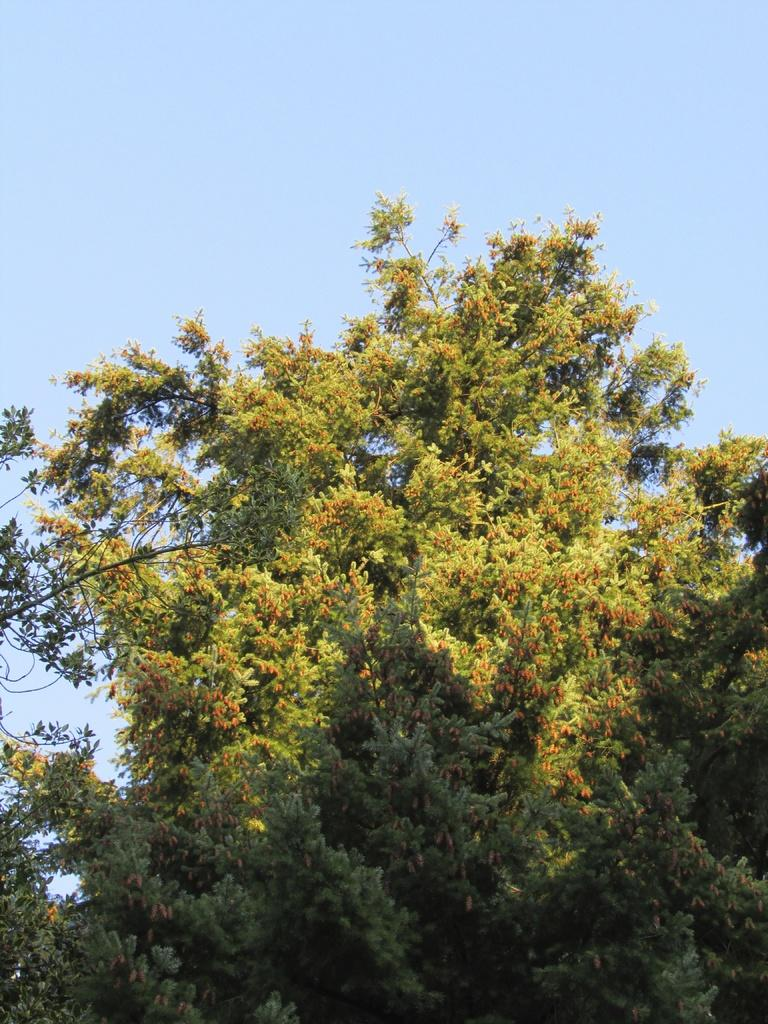What type of vegetation can be seen in the image? There are trees in the image. What is visible at the top of the image? The sky is visible at the top of the image. Where are the tree leaves and branches located in the image? Tree leaves and branches are present on the right side of the image. Can you see a toothbrush hanging from one of the tree branches in the image? No, there is no toothbrush present in the image. 